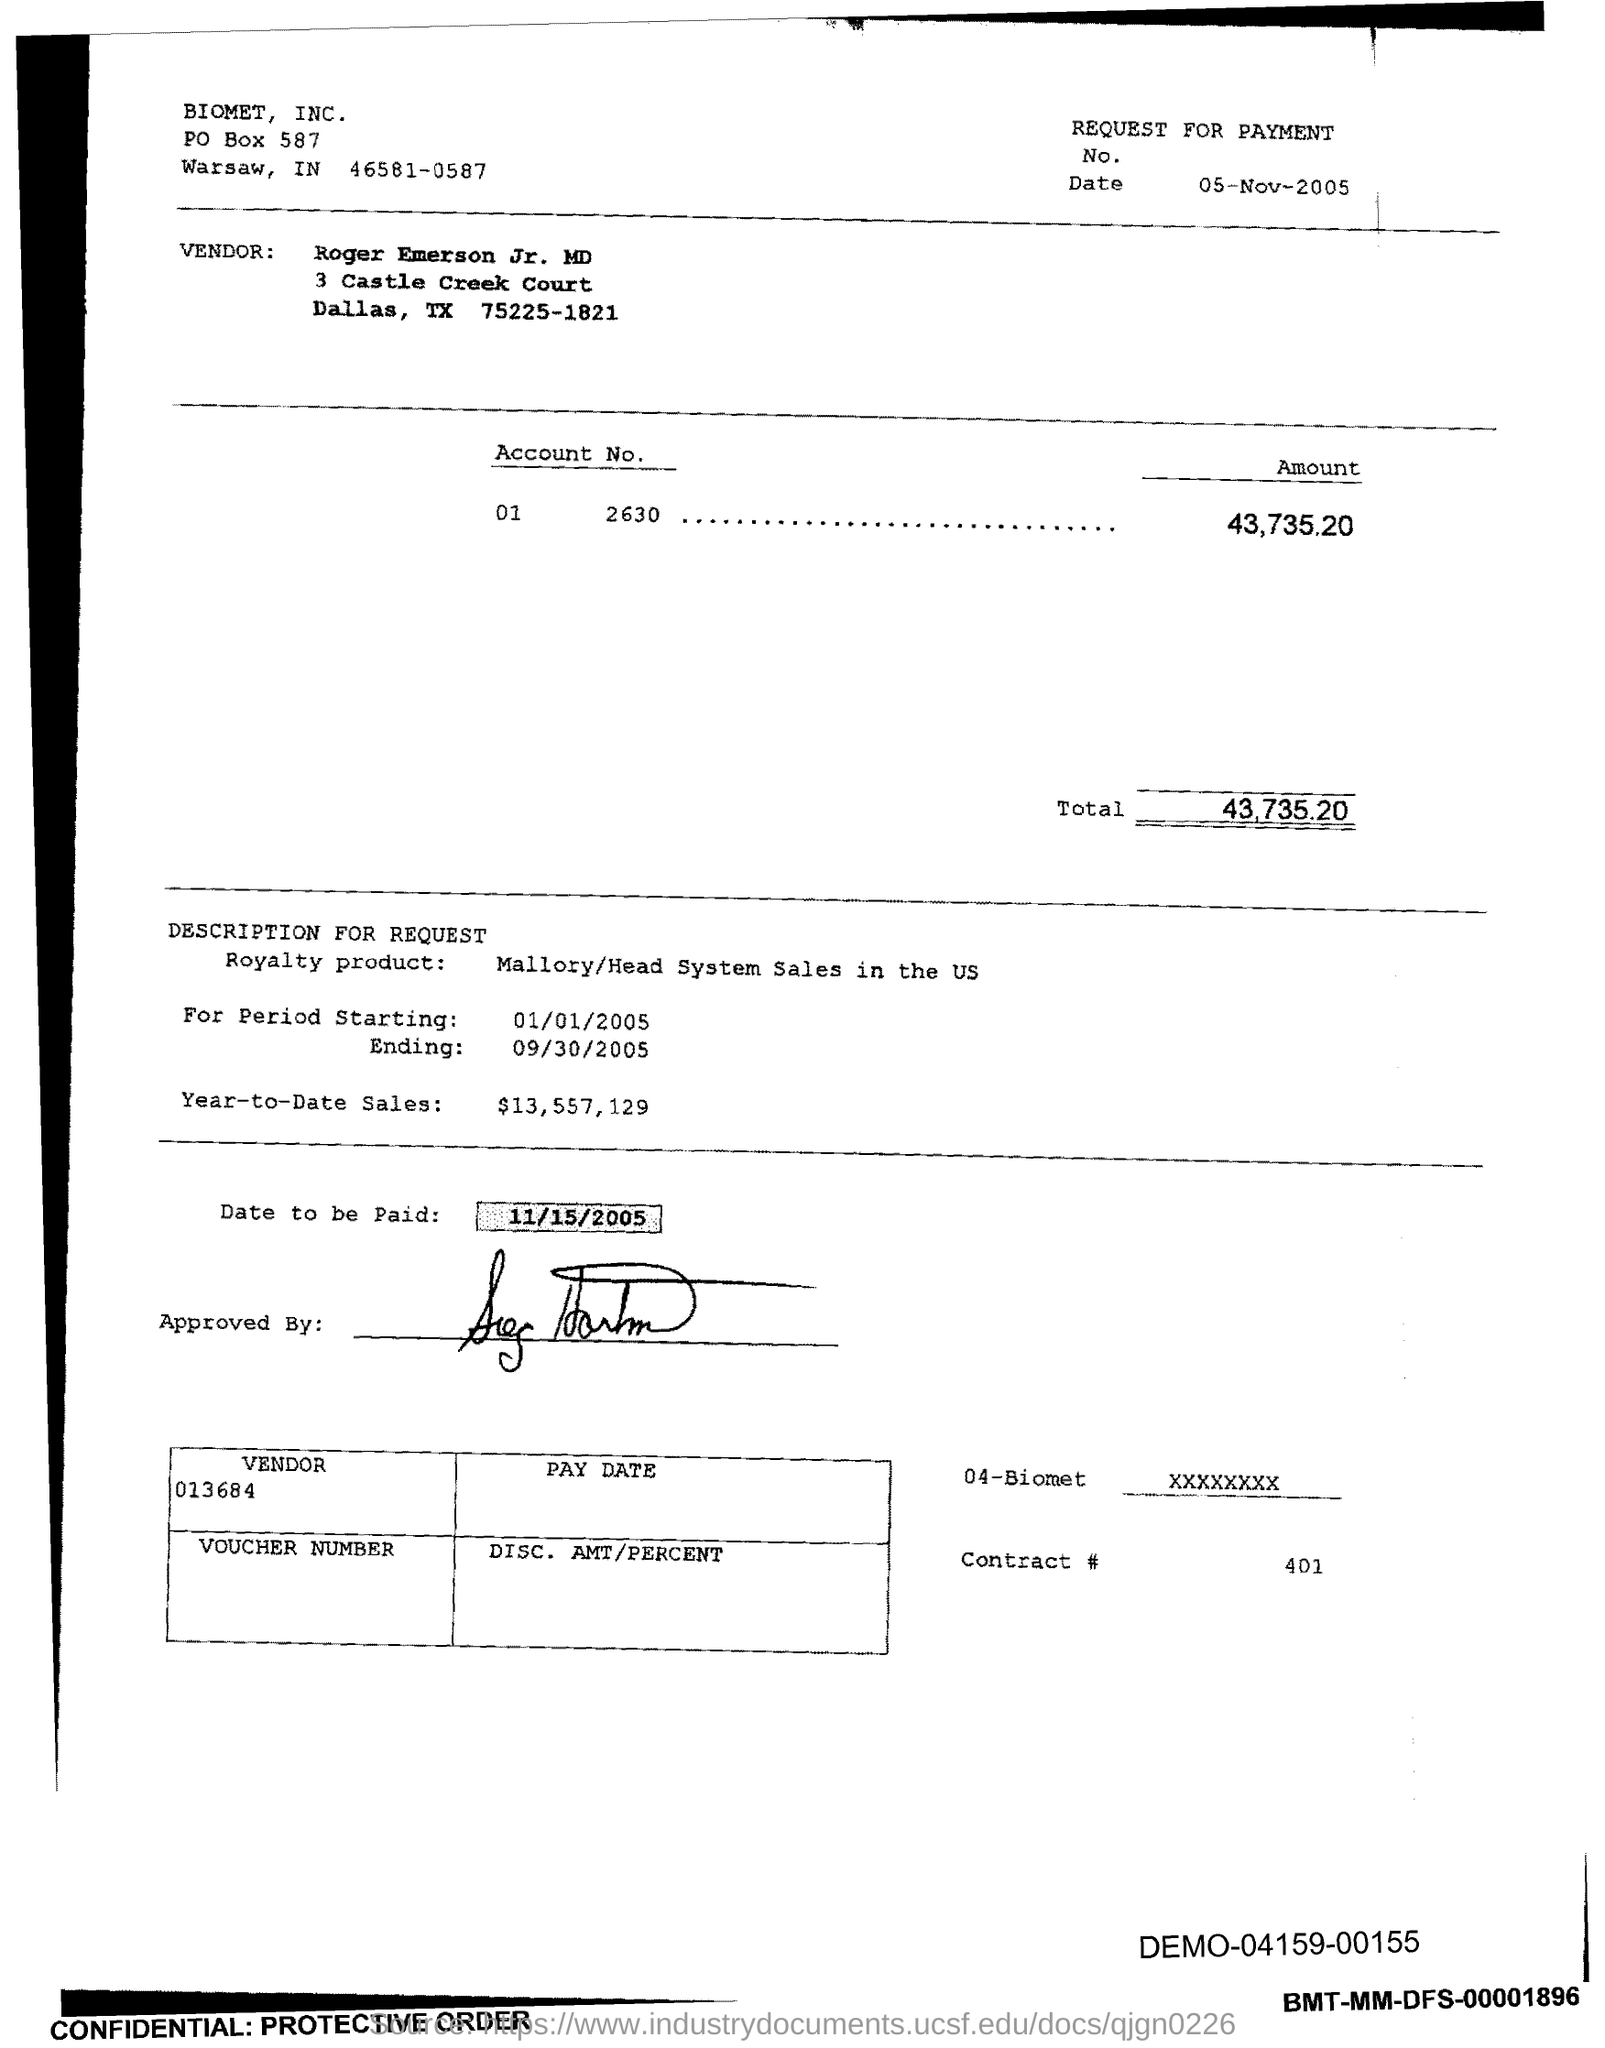How much is the total amount?
Provide a short and direct response. 43,735.20. The vendor is from which city?
Provide a short and direct response. Dallas. How much is the year to date sales amount?
Your response must be concise. $13,557,129. What is the starting date?
Provide a short and direct response. 01/01/2005. What is the date to be paid?
Offer a terse response. 11/15/2005. What is the vendor code?
Provide a short and direct response. 013684. What is the contract #?
Give a very brief answer. 401. What is the post box number of Biomet?
Your response must be concise. 587. What is the demo code mentioned in the bottom right corner?
Make the answer very short. 04159-00155. 